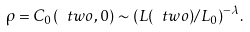Convert formula to latex. <formula><loc_0><loc_0><loc_500><loc_500>\rho = C _ { 0 } ( \ t w o , 0 ) \sim ( L ( \ t w o ) / L _ { 0 } ) ^ { - \lambda } .</formula> 